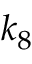Convert formula to latex. <formula><loc_0><loc_0><loc_500><loc_500>k _ { 8 }</formula> 